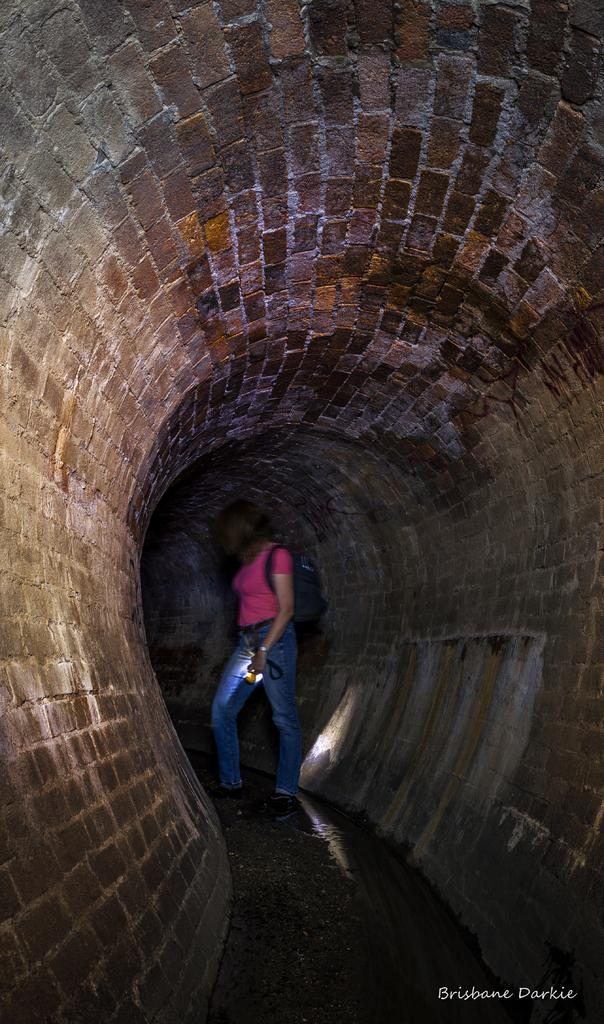Who is present in the image? There is a person in the image. Where is the person located? The person is standing inside a cave. What is the person wearing? The person is wearing a pink t-shirt and jeans. What is the person carrying? The person is carrying a bag. What is the person holding? The person is holding a torch. Can you see the person's smile in the image? There is no mention of the person's smile in the provided facts, so we cannot determine if the person is smiling or not from the image. 